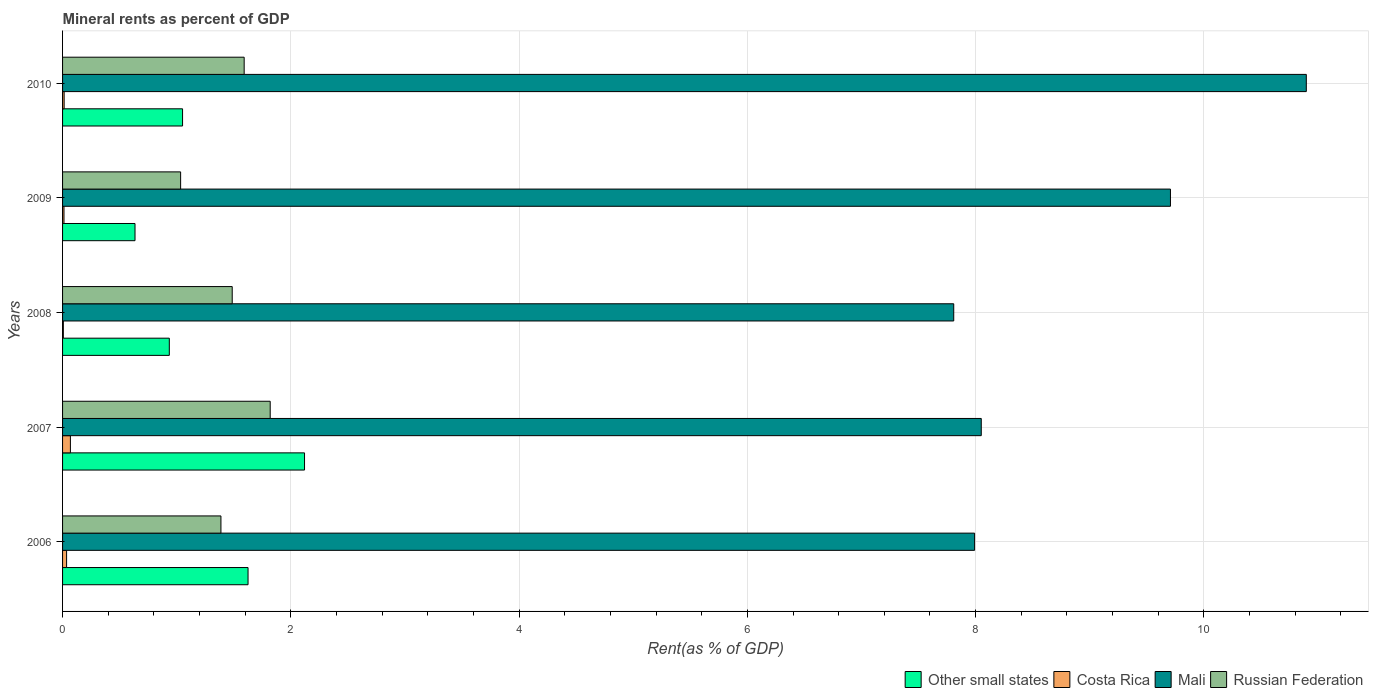Are the number of bars per tick equal to the number of legend labels?
Ensure brevity in your answer.  Yes. How many bars are there on the 4th tick from the bottom?
Make the answer very short. 4. In how many cases, is the number of bars for a given year not equal to the number of legend labels?
Give a very brief answer. 0. What is the mineral rent in Other small states in 2008?
Your answer should be very brief. 0.94. Across all years, what is the maximum mineral rent in Russian Federation?
Your answer should be compact. 1.82. Across all years, what is the minimum mineral rent in Other small states?
Your answer should be compact. 0.63. What is the total mineral rent in Other small states in the graph?
Your answer should be compact. 6.37. What is the difference between the mineral rent in Mali in 2006 and that in 2010?
Offer a very short reply. -2.91. What is the difference between the mineral rent in Costa Rica in 2006 and the mineral rent in Russian Federation in 2007?
Your response must be concise. -1.78. What is the average mineral rent in Mali per year?
Your answer should be compact. 8.89. In the year 2010, what is the difference between the mineral rent in Costa Rica and mineral rent in Other small states?
Keep it short and to the point. -1.04. In how many years, is the mineral rent in Costa Rica greater than 10 %?
Make the answer very short. 0. What is the ratio of the mineral rent in Russian Federation in 2008 to that in 2010?
Offer a very short reply. 0.93. Is the difference between the mineral rent in Costa Rica in 2006 and 2008 greater than the difference between the mineral rent in Other small states in 2006 and 2008?
Your answer should be very brief. No. What is the difference between the highest and the second highest mineral rent in Mali?
Provide a succinct answer. 1.19. What is the difference between the highest and the lowest mineral rent in Russian Federation?
Give a very brief answer. 0.78. Is it the case that in every year, the sum of the mineral rent in Other small states and mineral rent in Russian Federation is greater than the sum of mineral rent in Mali and mineral rent in Costa Rica?
Your response must be concise. No. What does the 2nd bar from the top in 2010 represents?
Your answer should be very brief. Mali. What does the 4th bar from the bottom in 2006 represents?
Your response must be concise. Russian Federation. How many bars are there?
Give a very brief answer. 20. Are all the bars in the graph horizontal?
Keep it short and to the point. Yes. How many years are there in the graph?
Offer a terse response. 5. What is the difference between two consecutive major ticks on the X-axis?
Provide a succinct answer. 2. Are the values on the major ticks of X-axis written in scientific E-notation?
Your response must be concise. No. Does the graph contain grids?
Your answer should be very brief. Yes. How many legend labels are there?
Your response must be concise. 4. How are the legend labels stacked?
Your response must be concise. Horizontal. What is the title of the graph?
Your answer should be compact. Mineral rents as percent of GDP. Does "Puerto Rico" appear as one of the legend labels in the graph?
Your answer should be compact. No. What is the label or title of the X-axis?
Keep it short and to the point. Rent(as % of GDP). What is the Rent(as % of GDP) in Other small states in 2006?
Offer a terse response. 1.63. What is the Rent(as % of GDP) of Costa Rica in 2006?
Provide a short and direct response. 0.04. What is the Rent(as % of GDP) of Mali in 2006?
Ensure brevity in your answer.  7.99. What is the Rent(as % of GDP) of Russian Federation in 2006?
Your answer should be very brief. 1.39. What is the Rent(as % of GDP) in Other small states in 2007?
Your answer should be very brief. 2.12. What is the Rent(as % of GDP) in Costa Rica in 2007?
Give a very brief answer. 0.07. What is the Rent(as % of GDP) of Mali in 2007?
Provide a succinct answer. 8.05. What is the Rent(as % of GDP) in Russian Federation in 2007?
Offer a terse response. 1.82. What is the Rent(as % of GDP) in Other small states in 2008?
Provide a succinct answer. 0.94. What is the Rent(as % of GDP) in Costa Rica in 2008?
Ensure brevity in your answer.  0.01. What is the Rent(as % of GDP) of Mali in 2008?
Your response must be concise. 7.81. What is the Rent(as % of GDP) in Russian Federation in 2008?
Your response must be concise. 1.49. What is the Rent(as % of GDP) of Other small states in 2009?
Your answer should be compact. 0.63. What is the Rent(as % of GDP) of Costa Rica in 2009?
Give a very brief answer. 0.01. What is the Rent(as % of GDP) in Mali in 2009?
Give a very brief answer. 9.71. What is the Rent(as % of GDP) in Russian Federation in 2009?
Provide a succinct answer. 1.03. What is the Rent(as % of GDP) of Other small states in 2010?
Give a very brief answer. 1.05. What is the Rent(as % of GDP) of Costa Rica in 2010?
Your answer should be very brief. 0.01. What is the Rent(as % of GDP) of Mali in 2010?
Ensure brevity in your answer.  10.9. What is the Rent(as % of GDP) in Russian Federation in 2010?
Your answer should be compact. 1.59. Across all years, what is the maximum Rent(as % of GDP) of Other small states?
Keep it short and to the point. 2.12. Across all years, what is the maximum Rent(as % of GDP) of Costa Rica?
Ensure brevity in your answer.  0.07. Across all years, what is the maximum Rent(as % of GDP) in Mali?
Give a very brief answer. 10.9. Across all years, what is the maximum Rent(as % of GDP) of Russian Federation?
Offer a terse response. 1.82. Across all years, what is the minimum Rent(as % of GDP) in Other small states?
Your answer should be compact. 0.63. Across all years, what is the minimum Rent(as % of GDP) of Costa Rica?
Provide a succinct answer. 0.01. Across all years, what is the minimum Rent(as % of GDP) in Mali?
Your answer should be very brief. 7.81. Across all years, what is the minimum Rent(as % of GDP) of Russian Federation?
Make the answer very short. 1.03. What is the total Rent(as % of GDP) in Other small states in the graph?
Ensure brevity in your answer.  6.37. What is the total Rent(as % of GDP) in Costa Rica in the graph?
Your response must be concise. 0.14. What is the total Rent(as % of GDP) in Mali in the graph?
Your response must be concise. 44.45. What is the total Rent(as % of GDP) in Russian Federation in the graph?
Ensure brevity in your answer.  7.32. What is the difference between the Rent(as % of GDP) of Other small states in 2006 and that in 2007?
Make the answer very short. -0.49. What is the difference between the Rent(as % of GDP) of Costa Rica in 2006 and that in 2007?
Offer a very short reply. -0.03. What is the difference between the Rent(as % of GDP) of Mali in 2006 and that in 2007?
Offer a very short reply. -0.06. What is the difference between the Rent(as % of GDP) of Russian Federation in 2006 and that in 2007?
Provide a succinct answer. -0.43. What is the difference between the Rent(as % of GDP) in Other small states in 2006 and that in 2008?
Keep it short and to the point. 0.69. What is the difference between the Rent(as % of GDP) of Costa Rica in 2006 and that in 2008?
Your response must be concise. 0.03. What is the difference between the Rent(as % of GDP) in Mali in 2006 and that in 2008?
Your response must be concise. 0.18. What is the difference between the Rent(as % of GDP) of Russian Federation in 2006 and that in 2008?
Your answer should be very brief. -0.1. What is the difference between the Rent(as % of GDP) of Other small states in 2006 and that in 2009?
Your response must be concise. 0.99. What is the difference between the Rent(as % of GDP) in Costa Rica in 2006 and that in 2009?
Your answer should be compact. 0.02. What is the difference between the Rent(as % of GDP) of Mali in 2006 and that in 2009?
Give a very brief answer. -1.72. What is the difference between the Rent(as % of GDP) in Russian Federation in 2006 and that in 2009?
Offer a terse response. 0.35. What is the difference between the Rent(as % of GDP) in Other small states in 2006 and that in 2010?
Keep it short and to the point. 0.57. What is the difference between the Rent(as % of GDP) in Costa Rica in 2006 and that in 2010?
Your answer should be very brief. 0.02. What is the difference between the Rent(as % of GDP) in Mali in 2006 and that in 2010?
Provide a succinct answer. -2.91. What is the difference between the Rent(as % of GDP) in Russian Federation in 2006 and that in 2010?
Provide a succinct answer. -0.2. What is the difference between the Rent(as % of GDP) of Other small states in 2007 and that in 2008?
Make the answer very short. 1.18. What is the difference between the Rent(as % of GDP) in Costa Rica in 2007 and that in 2008?
Keep it short and to the point. 0.06. What is the difference between the Rent(as % of GDP) in Mali in 2007 and that in 2008?
Keep it short and to the point. 0.24. What is the difference between the Rent(as % of GDP) in Russian Federation in 2007 and that in 2008?
Your response must be concise. 0.33. What is the difference between the Rent(as % of GDP) in Other small states in 2007 and that in 2009?
Offer a terse response. 1.49. What is the difference between the Rent(as % of GDP) in Costa Rica in 2007 and that in 2009?
Your answer should be compact. 0.06. What is the difference between the Rent(as % of GDP) of Mali in 2007 and that in 2009?
Provide a short and direct response. -1.66. What is the difference between the Rent(as % of GDP) in Russian Federation in 2007 and that in 2009?
Your response must be concise. 0.78. What is the difference between the Rent(as % of GDP) in Other small states in 2007 and that in 2010?
Make the answer very short. 1.07. What is the difference between the Rent(as % of GDP) of Costa Rica in 2007 and that in 2010?
Your answer should be very brief. 0.05. What is the difference between the Rent(as % of GDP) of Mali in 2007 and that in 2010?
Provide a succinct answer. -2.85. What is the difference between the Rent(as % of GDP) in Russian Federation in 2007 and that in 2010?
Make the answer very short. 0.23. What is the difference between the Rent(as % of GDP) in Other small states in 2008 and that in 2009?
Your response must be concise. 0.3. What is the difference between the Rent(as % of GDP) in Costa Rica in 2008 and that in 2009?
Give a very brief answer. -0.01. What is the difference between the Rent(as % of GDP) in Mali in 2008 and that in 2009?
Provide a short and direct response. -1.9. What is the difference between the Rent(as % of GDP) in Russian Federation in 2008 and that in 2009?
Your response must be concise. 0.45. What is the difference between the Rent(as % of GDP) in Other small states in 2008 and that in 2010?
Make the answer very short. -0.12. What is the difference between the Rent(as % of GDP) of Costa Rica in 2008 and that in 2010?
Your answer should be very brief. -0.01. What is the difference between the Rent(as % of GDP) of Mali in 2008 and that in 2010?
Keep it short and to the point. -3.09. What is the difference between the Rent(as % of GDP) in Russian Federation in 2008 and that in 2010?
Your response must be concise. -0.1. What is the difference between the Rent(as % of GDP) in Other small states in 2009 and that in 2010?
Keep it short and to the point. -0.42. What is the difference between the Rent(as % of GDP) in Costa Rica in 2009 and that in 2010?
Your answer should be very brief. -0. What is the difference between the Rent(as % of GDP) in Mali in 2009 and that in 2010?
Offer a terse response. -1.19. What is the difference between the Rent(as % of GDP) in Russian Federation in 2009 and that in 2010?
Provide a short and direct response. -0.56. What is the difference between the Rent(as % of GDP) in Other small states in 2006 and the Rent(as % of GDP) in Costa Rica in 2007?
Provide a succinct answer. 1.56. What is the difference between the Rent(as % of GDP) of Other small states in 2006 and the Rent(as % of GDP) of Mali in 2007?
Your response must be concise. -6.42. What is the difference between the Rent(as % of GDP) in Other small states in 2006 and the Rent(as % of GDP) in Russian Federation in 2007?
Ensure brevity in your answer.  -0.19. What is the difference between the Rent(as % of GDP) in Costa Rica in 2006 and the Rent(as % of GDP) in Mali in 2007?
Offer a very short reply. -8.01. What is the difference between the Rent(as % of GDP) in Costa Rica in 2006 and the Rent(as % of GDP) in Russian Federation in 2007?
Your answer should be compact. -1.78. What is the difference between the Rent(as % of GDP) in Mali in 2006 and the Rent(as % of GDP) in Russian Federation in 2007?
Your response must be concise. 6.17. What is the difference between the Rent(as % of GDP) in Other small states in 2006 and the Rent(as % of GDP) in Costa Rica in 2008?
Offer a terse response. 1.62. What is the difference between the Rent(as % of GDP) in Other small states in 2006 and the Rent(as % of GDP) in Mali in 2008?
Give a very brief answer. -6.18. What is the difference between the Rent(as % of GDP) in Other small states in 2006 and the Rent(as % of GDP) in Russian Federation in 2008?
Give a very brief answer. 0.14. What is the difference between the Rent(as % of GDP) of Costa Rica in 2006 and the Rent(as % of GDP) of Mali in 2008?
Give a very brief answer. -7.77. What is the difference between the Rent(as % of GDP) of Costa Rica in 2006 and the Rent(as % of GDP) of Russian Federation in 2008?
Provide a succinct answer. -1.45. What is the difference between the Rent(as % of GDP) of Mali in 2006 and the Rent(as % of GDP) of Russian Federation in 2008?
Offer a very short reply. 6.5. What is the difference between the Rent(as % of GDP) in Other small states in 2006 and the Rent(as % of GDP) in Costa Rica in 2009?
Provide a short and direct response. 1.61. What is the difference between the Rent(as % of GDP) of Other small states in 2006 and the Rent(as % of GDP) of Mali in 2009?
Your answer should be compact. -8.08. What is the difference between the Rent(as % of GDP) in Other small states in 2006 and the Rent(as % of GDP) in Russian Federation in 2009?
Offer a very short reply. 0.59. What is the difference between the Rent(as % of GDP) in Costa Rica in 2006 and the Rent(as % of GDP) in Mali in 2009?
Offer a very short reply. -9.67. What is the difference between the Rent(as % of GDP) in Costa Rica in 2006 and the Rent(as % of GDP) in Russian Federation in 2009?
Your answer should be very brief. -1. What is the difference between the Rent(as % of GDP) of Mali in 2006 and the Rent(as % of GDP) of Russian Federation in 2009?
Ensure brevity in your answer.  6.96. What is the difference between the Rent(as % of GDP) in Other small states in 2006 and the Rent(as % of GDP) in Costa Rica in 2010?
Offer a very short reply. 1.61. What is the difference between the Rent(as % of GDP) of Other small states in 2006 and the Rent(as % of GDP) of Mali in 2010?
Your answer should be compact. -9.27. What is the difference between the Rent(as % of GDP) of Other small states in 2006 and the Rent(as % of GDP) of Russian Federation in 2010?
Offer a very short reply. 0.03. What is the difference between the Rent(as % of GDP) of Costa Rica in 2006 and the Rent(as % of GDP) of Mali in 2010?
Make the answer very short. -10.86. What is the difference between the Rent(as % of GDP) in Costa Rica in 2006 and the Rent(as % of GDP) in Russian Federation in 2010?
Give a very brief answer. -1.56. What is the difference between the Rent(as % of GDP) of Mali in 2006 and the Rent(as % of GDP) of Russian Federation in 2010?
Your answer should be compact. 6.4. What is the difference between the Rent(as % of GDP) of Other small states in 2007 and the Rent(as % of GDP) of Costa Rica in 2008?
Offer a terse response. 2.11. What is the difference between the Rent(as % of GDP) of Other small states in 2007 and the Rent(as % of GDP) of Mali in 2008?
Keep it short and to the point. -5.69. What is the difference between the Rent(as % of GDP) in Other small states in 2007 and the Rent(as % of GDP) in Russian Federation in 2008?
Provide a short and direct response. 0.63. What is the difference between the Rent(as % of GDP) of Costa Rica in 2007 and the Rent(as % of GDP) of Mali in 2008?
Ensure brevity in your answer.  -7.74. What is the difference between the Rent(as % of GDP) in Costa Rica in 2007 and the Rent(as % of GDP) in Russian Federation in 2008?
Your answer should be compact. -1.42. What is the difference between the Rent(as % of GDP) in Mali in 2007 and the Rent(as % of GDP) in Russian Federation in 2008?
Offer a terse response. 6.56. What is the difference between the Rent(as % of GDP) of Other small states in 2007 and the Rent(as % of GDP) of Costa Rica in 2009?
Keep it short and to the point. 2.11. What is the difference between the Rent(as % of GDP) of Other small states in 2007 and the Rent(as % of GDP) of Mali in 2009?
Your answer should be very brief. -7.59. What is the difference between the Rent(as % of GDP) in Other small states in 2007 and the Rent(as % of GDP) in Russian Federation in 2009?
Provide a succinct answer. 1.09. What is the difference between the Rent(as % of GDP) of Costa Rica in 2007 and the Rent(as % of GDP) of Mali in 2009?
Your response must be concise. -9.64. What is the difference between the Rent(as % of GDP) of Costa Rica in 2007 and the Rent(as % of GDP) of Russian Federation in 2009?
Your response must be concise. -0.97. What is the difference between the Rent(as % of GDP) of Mali in 2007 and the Rent(as % of GDP) of Russian Federation in 2009?
Give a very brief answer. 7.01. What is the difference between the Rent(as % of GDP) in Other small states in 2007 and the Rent(as % of GDP) in Costa Rica in 2010?
Keep it short and to the point. 2.11. What is the difference between the Rent(as % of GDP) in Other small states in 2007 and the Rent(as % of GDP) in Mali in 2010?
Keep it short and to the point. -8.78. What is the difference between the Rent(as % of GDP) of Other small states in 2007 and the Rent(as % of GDP) of Russian Federation in 2010?
Offer a terse response. 0.53. What is the difference between the Rent(as % of GDP) in Costa Rica in 2007 and the Rent(as % of GDP) in Mali in 2010?
Your answer should be compact. -10.83. What is the difference between the Rent(as % of GDP) of Costa Rica in 2007 and the Rent(as % of GDP) of Russian Federation in 2010?
Give a very brief answer. -1.52. What is the difference between the Rent(as % of GDP) of Mali in 2007 and the Rent(as % of GDP) of Russian Federation in 2010?
Keep it short and to the point. 6.46. What is the difference between the Rent(as % of GDP) of Other small states in 2008 and the Rent(as % of GDP) of Costa Rica in 2009?
Provide a succinct answer. 0.92. What is the difference between the Rent(as % of GDP) in Other small states in 2008 and the Rent(as % of GDP) in Mali in 2009?
Offer a terse response. -8.77. What is the difference between the Rent(as % of GDP) in Other small states in 2008 and the Rent(as % of GDP) in Russian Federation in 2009?
Keep it short and to the point. -0.1. What is the difference between the Rent(as % of GDP) of Costa Rica in 2008 and the Rent(as % of GDP) of Russian Federation in 2009?
Provide a short and direct response. -1.03. What is the difference between the Rent(as % of GDP) in Mali in 2008 and the Rent(as % of GDP) in Russian Federation in 2009?
Your response must be concise. 6.77. What is the difference between the Rent(as % of GDP) in Other small states in 2008 and the Rent(as % of GDP) in Costa Rica in 2010?
Keep it short and to the point. 0.92. What is the difference between the Rent(as % of GDP) of Other small states in 2008 and the Rent(as % of GDP) of Mali in 2010?
Offer a terse response. -9.96. What is the difference between the Rent(as % of GDP) of Other small states in 2008 and the Rent(as % of GDP) of Russian Federation in 2010?
Your response must be concise. -0.66. What is the difference between the Rent(as % of GDP) of Costa Rica in 2008 and the Rent(as % of GDP) of Mali in 2010?
Your response must be concise. -10.89. What is the difference between the Rent(as % of GDP) in Costa Rica in 2008 and the Rent(as % of GDP) in Russian Federation in 2010?
Your answer should be very brief. -1.58. What is the difference between the Rent(as % of GDP) in Mali in 2008 and the Rent(as % of GDP) in Russian Federation in 2010?
Your response must be concise. 6.22. What is the difference between the Rent(as % of GDP) in Other small states in 2009 and the Rent(as % of GDP) in Costa Rica in 2010?
Offer a terse response. 0.62. What is the difference between the Rent(as % of GDP) in Other small states in 2009 and the Rent(as % of GDP) in Mali in 2010?
Your answer should be very brief. -10.26. What is the difference between the Rent(as % of GDP) of Other small states in 2009 and the Rent(as % of GDP) of Russian Federation in 2010?
Offer a terse response. -0.96. What is the difference between the Rent(as % of GDP) in Costa Rica in 2009 and the Rent(as % of GDP) in Mali in 2010?
Provide a short and direct response. -10.88. What is the difference between the Rent(as % of GDP) of Costa Rica in 2009 and the Rent(as % of GDP) of Russian Federation in 2010?
Your answer should be compact. -1.58. What is the difference between the Rent(as % of GDP) in Mali in 2009 and the Rent(as % of GDP) in Russian Federation in 2010?
Provide a succinct answer. 8.12. What is the average Rent(as % of GDP) of Other small states per year?
Make the answer very short. 1.27. What is the average Rent(as % of GDP) of Costa Rica per year?
Your answer should be compact. 0.03. What is the average Rent(as % of GDP) of Mali per year?
Your answer should be very brief. 8.89. What is the average Rent(as % of GDP) of Russian Federation per year?
Give a very brief answer. 1.46. In the year 2006, what is the difference between the Rent(as % of GDP) of Other small states and Rent(as % of GDP) of Costa Rica?
Your response must be concise. 1.59. In the year 2006, what is the difference between the Rent(as % of GDP) in Other small states and Rent(as % of GDP) in Mali?
Your answer should be compact. -6.37. In the year 2006, what is the difference between the Rent(as % of GDP) in Other small states and Rent(as % of GDP) in Russian Federation?
Ensure brevity in your answer.  0.24. In the year 2006, what is the difference between the Rent(as % of GDP) in Costa Rica and Rent(as % of GDP) in Mali?
Make the answer very short. -7.96. In the year 2006, what is the difference between the Rent(as % of GDP) of Costa Rica and Rent(as % of GDP) of Russian Federation?
Offer a very short reply. -1.35. In the year 2006, what is the difference between the Rent(as % of GDP) in Mali and Rent(as % of GDP) in Russian Federation?
Your answer should be very brief. 6.6. In the year 2007, what is the difference between the Rent(as % of GDP) of Other small states and Rent(as % of GDP) of Costa Rica?
Your response must be concise. 2.05. In the year 2007, what is the difference between the Rent(as % of GDP) in Other small states and Rent(as % of GDP) in Mali?
Offer a terse response. -5.93. In the year 2007, what is the difference between the Rent(as % of GDP) of Other small states and Rent(as % of GDP) of Russian Federation?
Give a very brief answer. 0.3. In the year 2007, what is the difference between the Rent(as % of GDP) of Costa Rica and Rent(as % of GDP) of Mali?
Keep it short and to the point. -7.98. In the year 2007, what is the difference between the Rent(as % of GDP) in Costa Rica and Rent(as % of GDP) in Russian Federation?
Your response must be concise. -1.75. In the year 2007, what is the difference between the Rent(as % of GDP) of Mali and Rent(as % of GDP) of Russian Federation?
Ensure brevity in your answer.  6.23. In the year 2008, what is the difference between the Rent(as % of GDP) in Other small states and Rent(as % of GDP) in Costa Rica?
Your answer should be compact. 0.93. In the year 2008, what is the difference between the Rent(as % of GDP) in Other small states and Rent(as % of GDP) in Mali?
Ensure brevity in your answer.  -6.87. In the year 2008, what is the difference between the Rent(as % of GDP) in Other small states and Rent(as % of GDP) in Russian Federation?
Ensure brevity in your answer.  -0.55. In the year 2008, what is the difference between the Rent(as % of GDP) in Costa Rica and Rent(as % of GDP) in Mali?
Offer a very short reply. -7.8. In the year 2008, what is the difference between the Rent(as % of GDP) in Costa Rica and Rent(as % of GDP) in Russian Federation?
Offer a terse response. -1.48. In the year 2008, what is the difference between the Rent(as % of GDP) in Mali and Rent(as % of GDP) in Russian Federation?
Make the answer very short. 6.32. In the year 2009, what is the difference between the Rent(as % of GDP) of Other small states and Rent(as % of GDP) of Costa Rica?
Keep it short and to the point. 0.62. In the year 2009, what is the difference between the Rent(as % of GDP) of Other small states and Rent(as % of GDP) of Mali?
Give a very brief answer. -9.07. In the year 2009, what is the difference between the Rent(as % of GDP) in Other small states and Rent(as % of GDP) in Russian Federation?
Your answer should be very brief. -0.4. In the year 2009, what is the difference between the Rent(as % of GDP) in Costa Rica and Rent(as % of GDP) in Mali?
Keep it short and to the point. -9.69. In the year 2009, what is the difference between the Rent(as % of GDP) in Costa Rica and Rent(as % of GDP) in Russian Federation?
Offer a terse response. -1.02. In the year 2009, what is the difference between the Rent(as % of GDP) of Mali and Rent(as % of GDP) of Russian Federation?
Your answer should be compact. 8.67. In the year 2010, what is the difference between the Rent(as % of GDP) in Other small states and Rent(as % of GDP) in Costa Rica?
Offer a terse response. 1.04. In the year 2010, what is the difference between the Rent(as % of GDP) in Other small states and Rent(as % of GDP) in Mali?
Keep it short and to the point. -9.85. In the year 2010, what is the difference between the Rent(as % of GDP) in Other small states and Rent(as % of GDP) in Russian Federation?
Make the answer very short. -0.54. In the year 2010, what is the difference between the Rent(as % of GDP) of Costa Rica and Rent(as % of GDP) of Mali?
Make the answer very short. -10.88. In the year 2010, what is the difference between the Rent(as % of GDP) of Costa Rica and Rent(as % of GDP) of Russian Federation?
Keep it short and to the point. -1.58. In the year 2010, what is the difference between the Rent(as % of GDP) in Mali and Rent(as % of GDP) in Russian Federation?
Give a very brief answer. 9.31. What is the ratio of the Rent(as % of GDP) in Other small states in 2006 to that in 2007?
Your answer should be very brief. 0.77. What is the ratio of the Rent(as % of GDP) of Costa Rica in 2006 to that in 2007?
Provide a short and direct response. 0.51. What is the ratio of the Rent(as % of GDP) in Russian Federation in 2006 to that in 2007?
Your answer should be compact. 0.76. What is the ratio of the Rent(as % of GDP) of Other small states in 2006 to that in 2008?
Provide a short and direct response. 1.74. What is the ratio of the Rent(as % of GDP) of Costa Rica in 2006 to that in 2008?
Your answer should be compact. 5.13. What is the ratio of the Rent(as % of GDP) of Mali in 2006 to that in 2008?
Your answer should be very brief. 1.02. What is the ratio of the Rent(as % of GDP) of Russian Federation in 2006 to that in 2008?
Your answer should be very brief. 0.93. What is the ratio of the Rent(as % of GDP) in Other small states in 2006 to that in 2009?
Provide a short and direct response. 2.56. What is the ratio of the Rent(as % of GDP) of Costa Rica in 2006 to that in 2009?
Make the answer very short. 2.84. What is the ratio of the Rent(as % of GDP) in Mali in 2006 to that in 2009?
Keep it short and to the point. 0.82. What is the ratio of the Rent(as % of GDP) in Russian Federation in 2006 to that in 2009?
Provide a short and direct response. 1.34. What is the ratio of the Rent(as % of GDP) in Other small states in 2006 to that in 2010?
Make the answer very short. 1.55. What is the ratio of the Rent(as % of GDP) in Costa Rica in 2006 to that in 2010?
Offer a terse response. 2.56. What is the ratio of the Rent(as % of GDP) in Mali in 2006 to that in 2010?
Keep it short and to the point. 0.73. What is the ratio of the Rent(as % of GDP) of Russian Federation in 2006 to that in 2010?
Your answer should be very brief. 0.87. What is the ratio of the Rent(as % of GDP) in Other small states in 2007 to that in 2008?
Offer a terse response. 2.27. What is the ratio of the Rent(as % of GDP) in Costa Rica in 2007 to that in 2008?
Offer a terse response. 9.99. What is the ratio of the Rent(as % of GDP) of Mali in 2007 to that in 2008?
Your response must be concise. 1.03. What is the ratio of the Rent(as % of GDP) of Russian Federation in 2007 to that in 2008?
Provide a short and direct response. 1.22. What is the ratio of the Rent(as % of GDP) of Other small states in 2007 to that in 2009?
Your response must be concise. 3.34. What is the ratio of the Rent(as % of GDP) in Costa Rica in 2007 to that in 2009?
Offer a very short reply. 5.52. What is the ratio of the Rent(as % of GDP) in Mali in 2007 to that in 2009?
Give a very brief answer. 0.83. What is the ratio of the Rent(as % of GDP) of Russian Federation in 2007 to that in 2009?
Give a very brief answer. 1.76. What is the ratio of the Rent(as % of GDP) of Other small states in 2007 to that in 2010?
Provide a succinct answer. 2.02. What is the ratio of the Rent(as % of GDP) of Costa Rica in 2007 to that in 2010?
Give a very brief answer. 4.97. What is the ratio of the Rent(as % of GDP) in Mali in 2007 to that in 2010?
Your answer should be compact. 0.74. What is the ratio of the Rent(as % of GDP) in Russian Federation in 2007 to that in 2010?
Give a very brief answer. 1.14. What is the ratio of the Rent(as % of GDP) in Other small states in 2008 to that in 2009?
Give a very brief answer. 1.47. What is the ratio of the Rent(as % of GDP) in Costa Rica in 2008 to that in 2009?
Offer a terse response. 0.55. What is the ratio of the Rent(as % of GDP) of Mali in 2008 to that in 2009?
Your response must be concise. 0.8. What is the ratio of the Rent(as % of GDP) of Russian Federation in 2008 to that in 2009?
Your answer should be compact. 1.44. What is the ratio of the Rent(as % of GDP) of Other small states in 2008 to that in 2010?
Provide a succinct answer. 0.89. What is the ratio of the Rent(as % of GDP) of Costa Rica in 2008 to that in 2010?
Ensure brevity in your answer.  0.5. What is the ratio of the Rent(as % of GDP) of Mali in 2008 to that in 2010?
Offer a terse response. 0.72. What is the ratio of the Rent(as % of GDP) in Russian Federation in 2008 to that in 2010?
Your response must be concise. 0.93. What is the ratio of the Rent(as % of GDP) of Other small states in 2009 to that in 2010?
Provide a succinct answer. 0.6. What is the ratio of the Rent(as % of GDP) in Costa Rica in 2009 to that in 2010?
Provide a short and direct response. 0.9. What is the ratio of the Rent(as % of GDP) of Mali in 2009 to that in 2010?
Your answer should be compact. 0.89. What is the ratio of the Rent(as % of GDP) of Russian Federation in 2009 to that in 2010?
Offer a very short reply. 0.65. What is the difference between the highest and the second highest Rent(as % of GDP) of Other small states?
Ensure brevity in your answer.  0.49. What is the difference between the highest and the second highest Rent(as % of GDP) of Costa Rica?
Your answer should be very brief. 0.03. What is the difference between the highest and the second highest Rent(as % of GDP) in Mali?
Offer a terse response. 1.19. What is the difference between the highest and the second highest Rent(as % of GDP) in Russian Federation?
Your answer should be very brief. 0.23. What is the difference between the highest and the lowest Rent(as % of GDP) of Other small states?
Offer a very short reply. 1.49. What is the difference between the highest and the lowest Rent(as % of GDP) in Costa Rica?
Ensure brevity in your answer.  0.06. What is the difference between the highest and the lowest Rent(as % of GDP) of Mali?
Make the answer very short. 3.09. What is the difference between the highest and the lowest Rent(as % of GDP) in Russian Federation?
Offer a terse response. 0.78. 